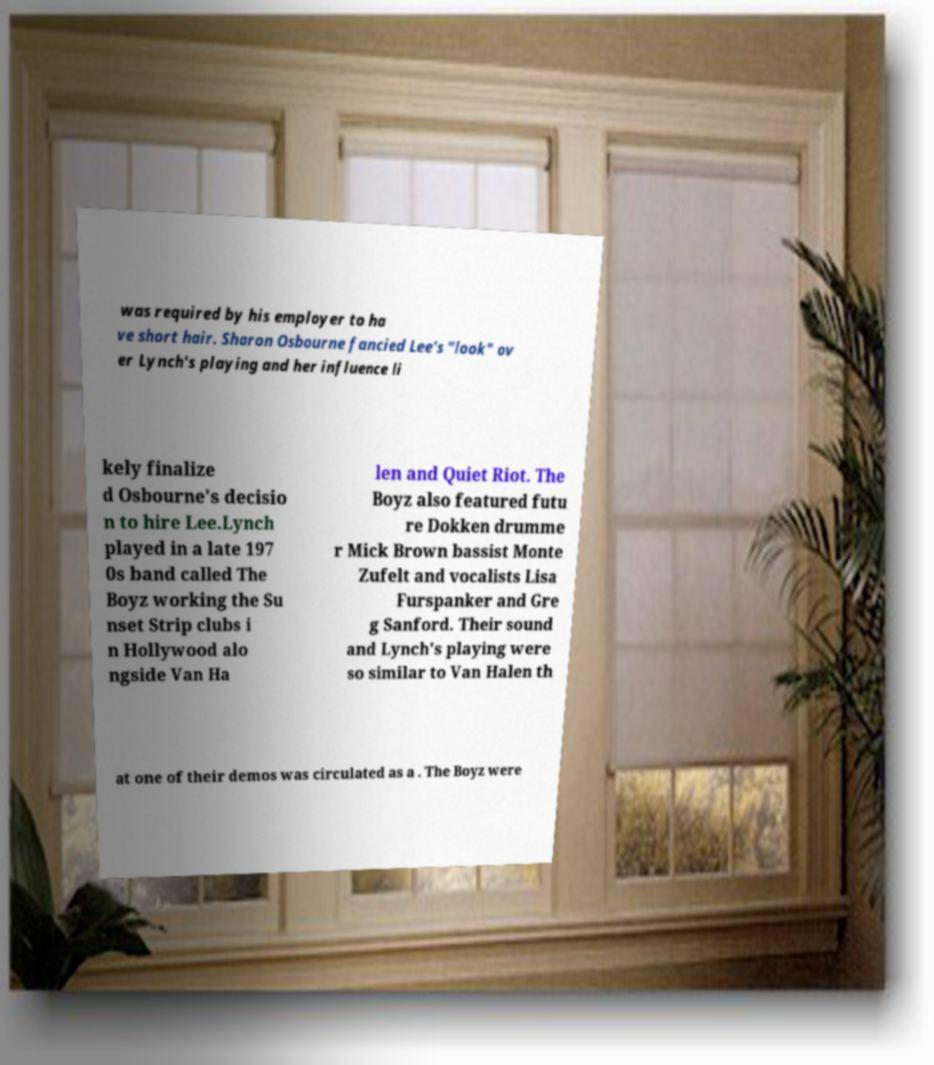Can you accurately transcribe the text from the provided image for me? was required by his employer to ha ve short hair. Sharon Osbourne fancied Lee's "look" ov er Lynch's playing and her influence li kely finalize d Osbourne's decisio n to hire Lee.Lynch played in a late 197 0s band called The Boyz working the Su nset Strip clubs i n Hollywood alo ngside Van Ha len and Quiet Riot. The Boyz also featured futu re Dokken drumme r Mick Brown bassist Monte Zufelt and vocalists Lisa Furspanker and Gre g Sanford. Their sound and Lynch's playing were so similar to Van Halen th at one of their demos was circulated as a . The Boyz were 